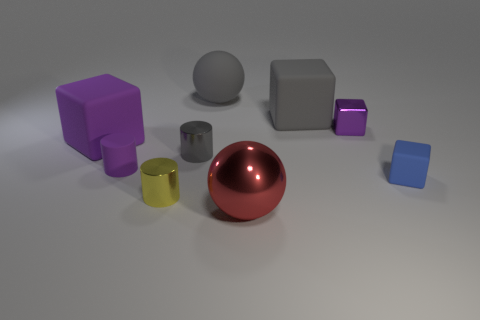There is a rubber block behind the big rubber cube that is to the left of the metal ball; is there a red object on the right side of it?
Make the answer very short. No. Do the big gray rubber thing to the left of the gray rubber cube and the small blue thing have the same shape?
Your response must be concise. No. What is the shape of the purple thing behind the big rubber thing on the left side of the purple matte cylinder?
Provide a succinct answer. Cube. There is a ball on the right side of the large ball behind the big matte block right of the tiny matte cylinder; how big is it?
Make the answer very short. Large. What is the color of the other rubber object that is the same shape as the yellow object?
Offer a terse response. Purple. Is the purple rubber cube the same size as the metal cube?
Provide a short and direct response. No. What material is the sphere behind the big purple cube?
Offer a very short reply. Rubber. How many other things are there of the same shape as the yellow metallic thing?
Make the answer very short. 2. Is the small blue matte object the same shape as the red object?
Give a very brief answer. No. There is a small purple rubber thing; are there any small gray cylinders in front of it?
Your answer should be compact. No. 